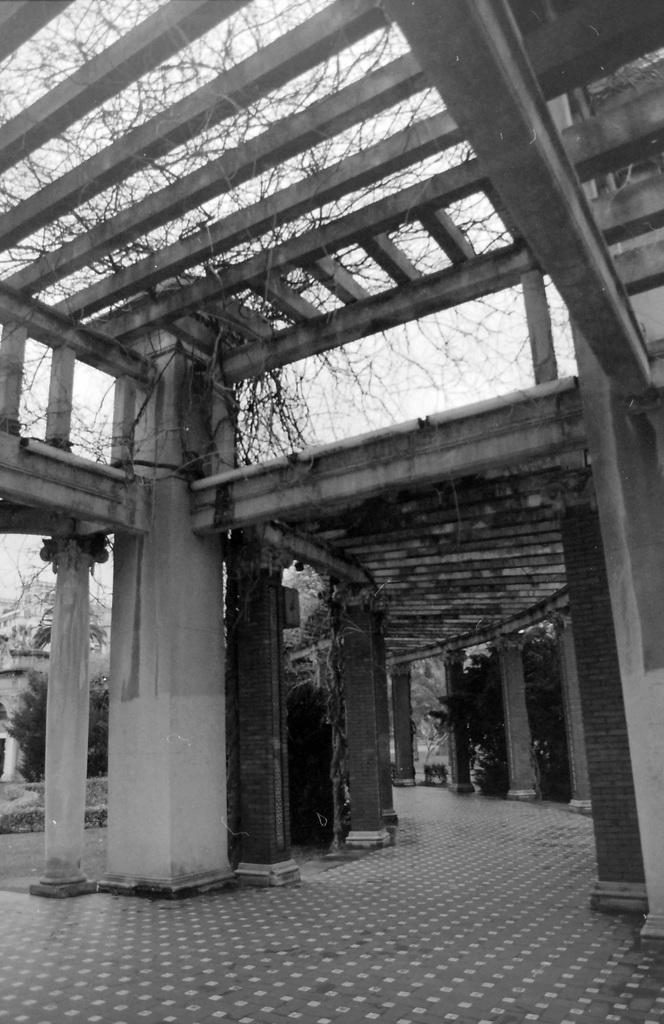Please provide a concise description of this image. This looks like a black and white image. I can see the pillars. This looks like a pathway. I think these are the branches, which are on the roof. On the right side of the image, I think this is a tree. 